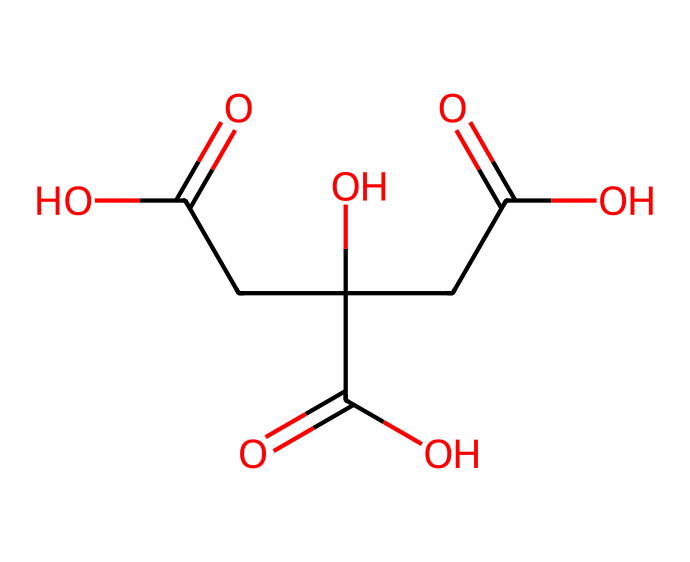What is the primary functional group in citric acid? The chemical structure has three carboxylic acid groups (-COOH) indicated by the presence of oxygen double-bonded to carbon and -OH groups. This makes carboxylic acid the primary functional group.
Answer: carboxylic acid How many carbon atoms are present in citric acid? By analyzing the SMILES representation, we can count six carbon atoms (C) represented in the entire structure.
Answer: six What is the total number of hydrogen atoms in citric acid? Each carboxylic acid adds one hydrogen atom, and the structure shows additional hydrogens bonded to the carbons. Counting gives us eight hydrogen atoms (H) total in the structure.
Answer: eight Why does citric acid lead to acidic marine environments? Citric acid ionizes in water to release protons (H+), lowering the pH and making the environment acidic. Since it has multiple carboxylic groups, it can release several protons.
Answer: proton release What is the molecular weight of citric acid? By calculating the atomic weights of the components: 6 carbon (C) atoms, 8 hydrogen (H) atoms, and 7 oxygen (O) atoms, we can sum them up to find the molecular weight is approximately 192.13 g/mol.
Answer: 192.13 g/mol 